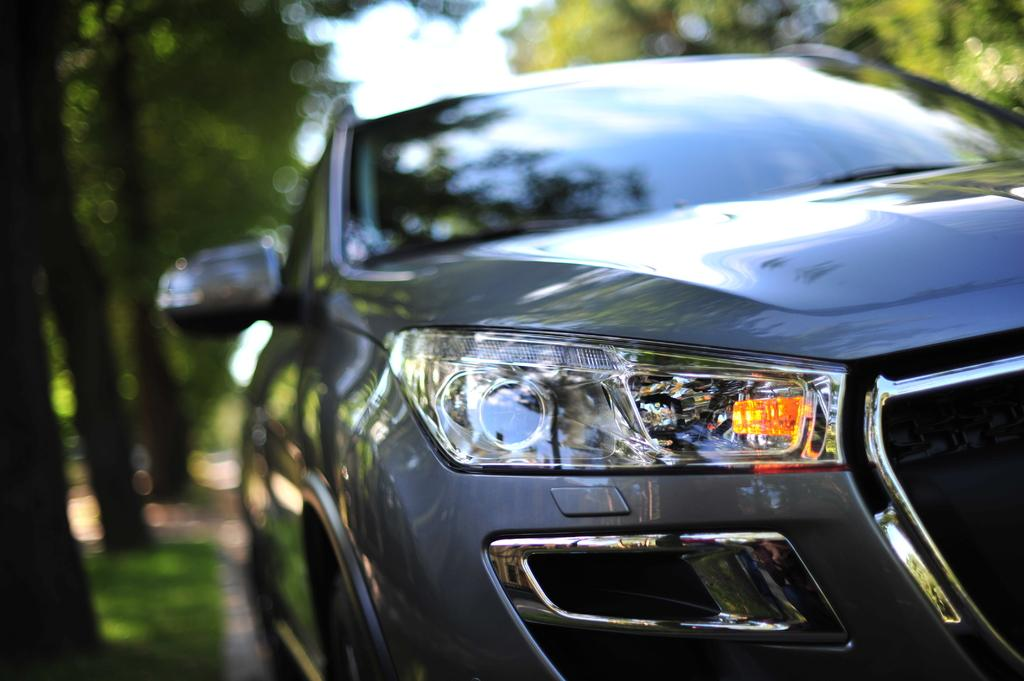What is the main subject of the image? There is a car in the image. Where is the car located? The car is on the road. What can be seen in the background of the image? There are trees and the sky visible in the background of the image. How many hens are sitting on the car in the image? There are no hens present in the image; it features a car on the road with trees and the sky in the background. 